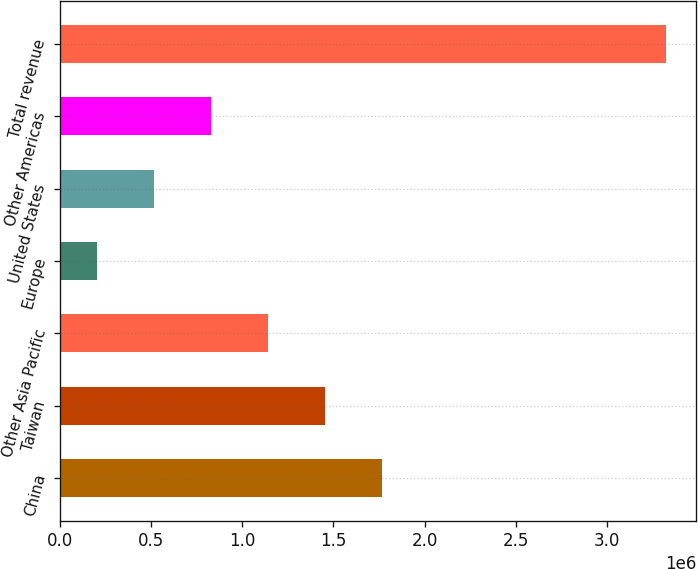Convert chart to OTSL. <chart><loc_0><loc_0><loc_500><loc_500><bar_chart><fcel>China<fcel>Taiwan<fcel>Other Asia Pacific<fcel>Europe<fcel>United States<fcel>Other Americas<fcel>Total revenue<nl><fcel>1.7651e+06<fcel>1.45283e+06<fcel>1.14057e+06<fcel>203760<fcel>516028<fcel>828297<fcel>3.32644e+06<nl></chart> 